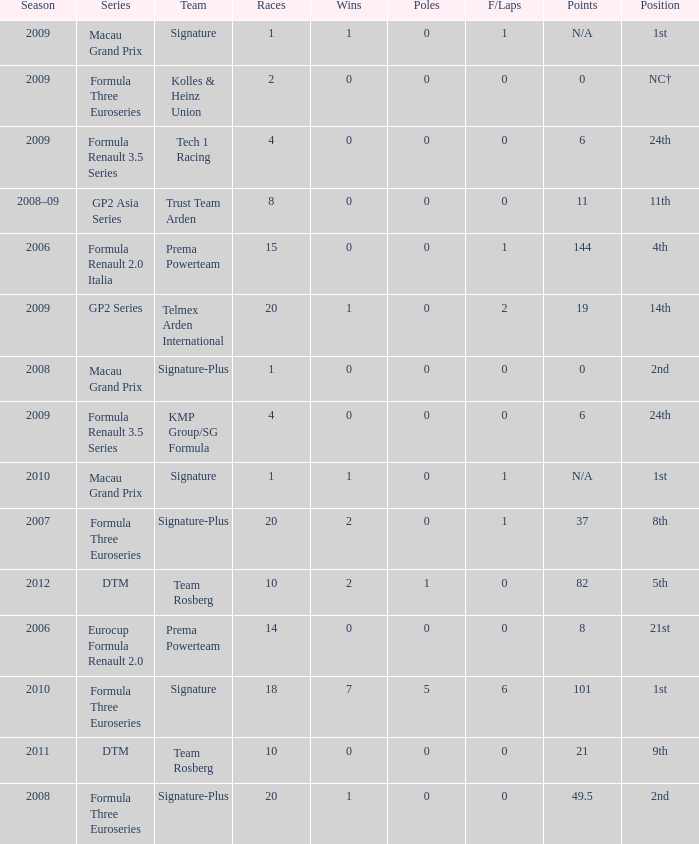How many races did the Formula Three Euroseries signature team have? 18.0. 